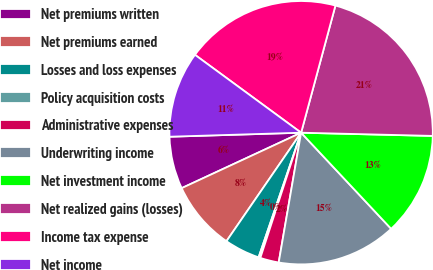Convert chart. <chart><loc_0><loc_0><loc_500><loc_500><pie_chart><fcel>Net premiums written<fcel>Net premiums earned<fcel>Losses and loss expenses<fcel>Policy acquisition costs<fcel>Administrative expenses<fcel>Underwriting income<fcel>Net investment income<fcel>Net realized gains (losses)<fcel>Income tax expense<fcel>Net income<nl><fcel>6.43%<fcel>8.49%<fcel>4.36%<fcel>0.22%<fcel>2.29%<fcel>14.7%<fcel>12.63%<fcel>21.19%<fcel>19.12%<fcel>10.56%<nl></chart> 